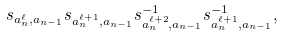Convert formula to latex. <formula><loc_0><loc_0><loc_500><loc_500>s _ { a _ { n } ^ { \ell } , a _ { n - 1 } } s _ { a _ { n } ^ { \ell + 1 } , a _ { n - 1 } } s _ { a _ { n } ^ { \ell + 2 } , a _ { n - 1 } } ^ { - 1 } s _ { a _ { n } ^ { \ell + 1 } , a _ { n - 1 } } ^ { - 1 } ,</formula> 